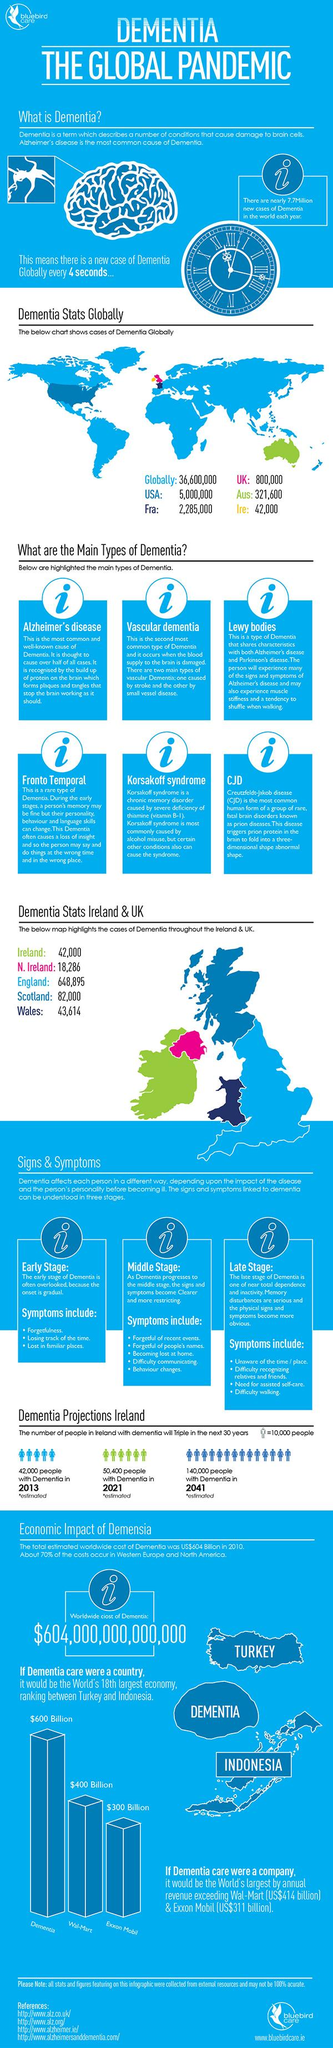Draw attention to some important aspects in this diagram. Four references are given. England has the highest number of dementia cases in both Ireland and the UK. Australia is represented by the color green on world maps. By 2041, the number of people with dementia in Ireland is projected to increase by 98,000. 